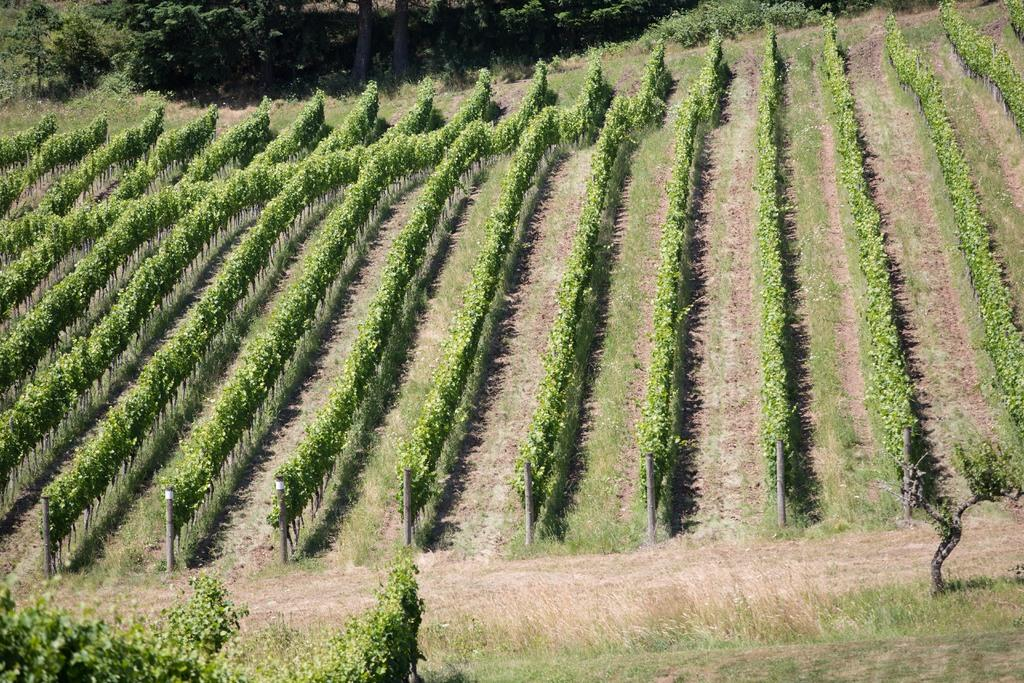What objects are present in the image that resemble long, vertical structures? There are poles in the image. What type of living organisms can be seen in the image? There are plants and trees in the image. What is the color of the plants in the image? The plants in the image are green in color. What is the color of the trees in the image? The trees in the image are green in color. What is the title of the book that is being read by the person on the island in the image? There is no person or island present in the image; it features poles, plants, and trees. What type of work is being performed by the person on the workbench in the image? There is no person or workbench present in the image; it features poles, plants, and trees. 